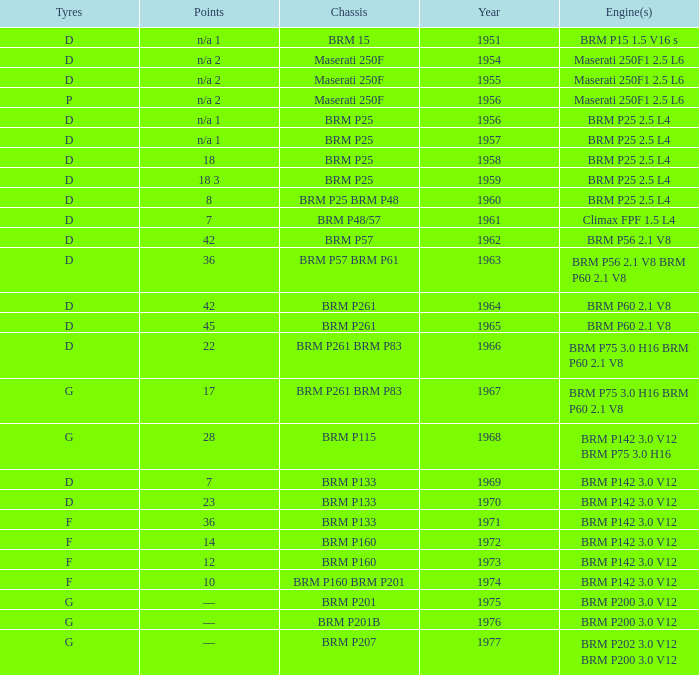Name the chassis of 1961 BRM P48/57. 